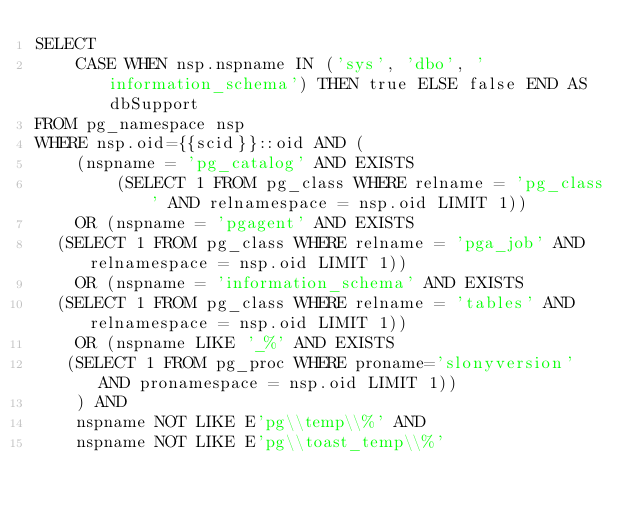<code> <loc_0><loc_0><loc_500><loc_500><_SQL_>SELECT
    CASE WHEN nsp.nspname IN ('sys', 'dbo', 'information_schema') THEN true ELSE false END AS dbSupport
FROM pg_namespace nsp
WHERE nsp.oid={{scid}}::oid AND (
    (nspname = 'pg_catalog' AND EXISTS
        (SELECT 1 FROM pg_class WHERE relname = 'pg_class' AND relnamespace = nsp.oid LIMIT 1))
    OR (nspname = 'pgagent' AND EXISTS
	(SELECT 1 FROM pg_class WHERE relname = 'pga_job' AND relnamespace = nsp.oid LIMIT 1))
    OR (nspname = 'information_schema' AND EXISTS
	(SELECT 1 FROM pg_class WHERE relname = 'tables' AND relnamespace = nsp.oid LIMIT 1))
    OR (nspname LIKE '_%' AND EXISTS
	 (SELECT 1 FROM pg_proc WHERE proname='slonyversion' AND pronamespace = nsp.oid LIMIT 1))
    ) AND
    nspname NOT LIKE E'pg\\temp\\%' AND
    nspname NOT LIKE E'pg\\toast_temp\\%'</code> 